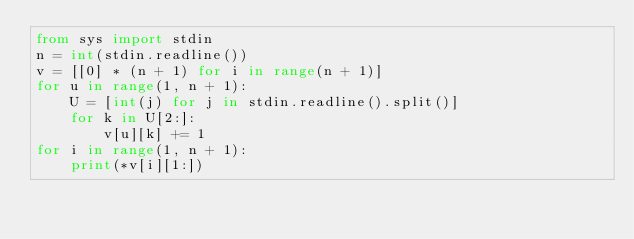<code> <loc_0><loc_0><loc_500><loc_500><_Python_>from sys import stdin
n = int(stdin.readline())
v = [[0] * (n + 1) for i in range(n + 1)]
for u in range(1, n + 1):
    U = [int(j) for j in stdin.readline().split()]
    for k in U[2:]:
        v[u][k] += 1
for i in range(1, n + 1):
    print(*v[i][1:])</code> 